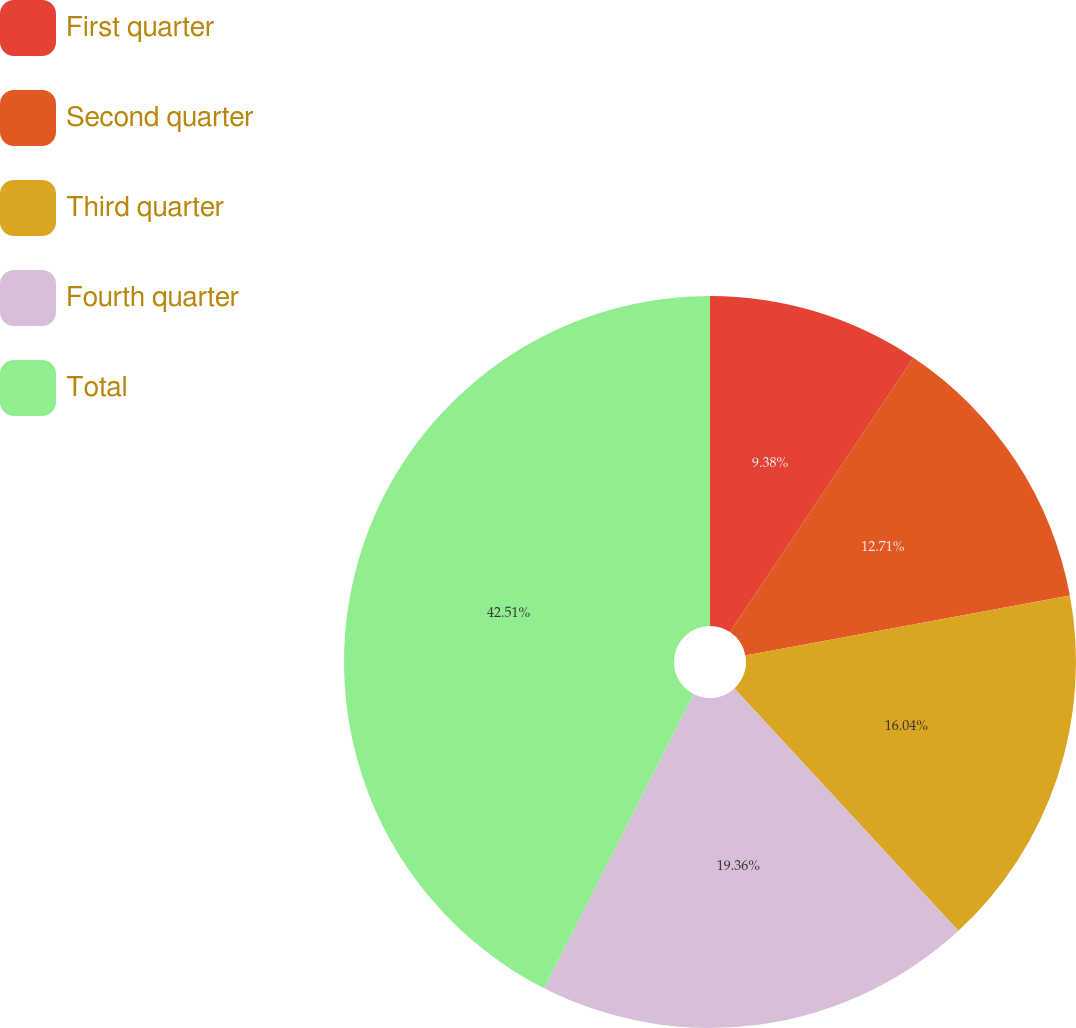Convert chart. <chart><loc_0><loc_0><loc_500><loc_500><pie_chart><fcel>First quarter<fcel>Second quarter<fcel>Third quarter<fcel>Fourth quarter<fcel>Total<nl><fcel>9.38%<fcel>12.71%<fcel>16.04%<fcel>19.36%<fcel>42.51%<nl></chart> 